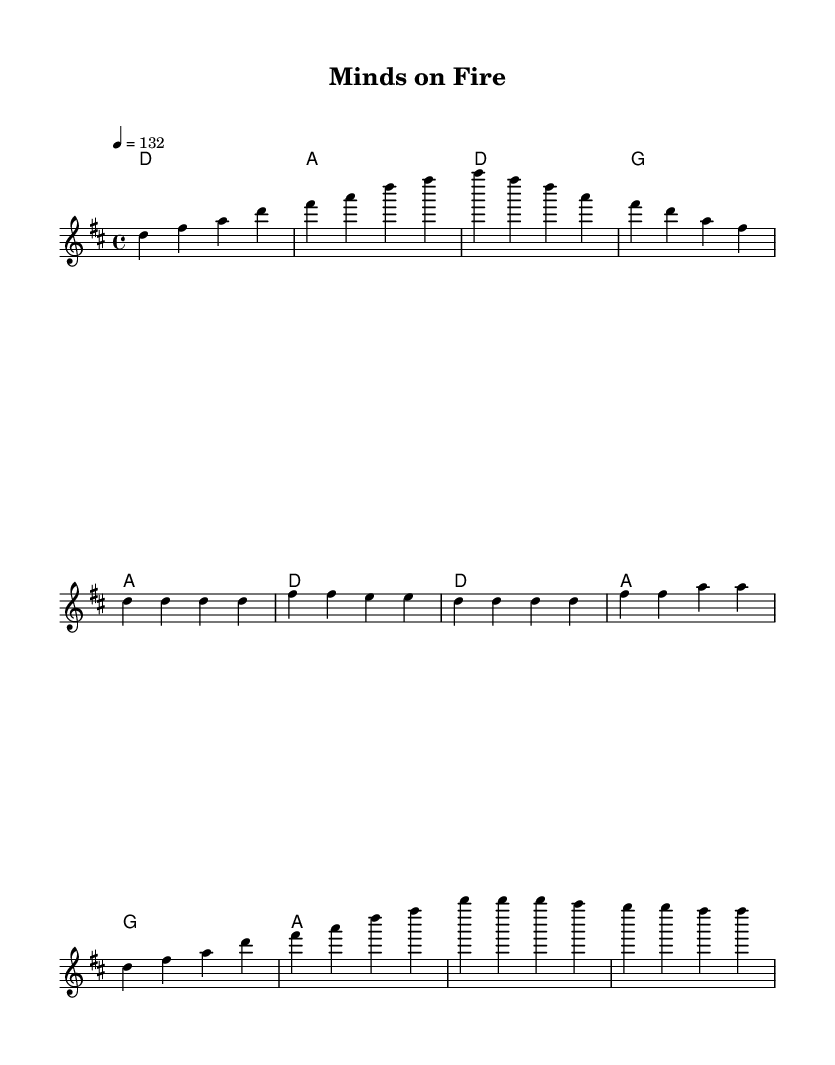What is the key signature of this music? The key signature is indicated at the beginning of the score, which shows two sharps. This corresponds to D major.
Answer: D major What is the time signature of this music? The time signature is shown at the beginning as 4/4, indicating four beats per measure with a quarter note receiving one beat.
Answer: 4/4 What is the tempo of this piece? The tempo marking is present at the beginning and indicates a speed of 132 beats per minute, noted as "4 = 132".
Answer: 132 How many measures are there in the chorus? The chorus section consists of four lines in the music sheet, which correlates to 4 measures of music based on the grouping of the notes.
Answer: 4 What is the first lyric line of the verse? The first lyric line is directly provided under the melody in the sheet music. It clearly starts with "Pages turning, midnight oil burning".
Answer: Pages turning, midnight oil burning How does the chorus begin musically? The chorus starts with the notes D, F#, A, indicating the melody line that leads into the lyrical content. The presence of these notes can be located in the scored chorus section.
Answer: D, F#, A What thematic element is emphasized in the lyrics? The lyrics reflect intellectual curiosity and a desire for learning, indicated by the phrases "Questions yearning, for answers earning" from the verse and "Minds on fire, reaching higher" from the chorus.
Answer: Intellectual curiosity 